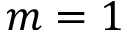Convert formula to latex. <formula><loc_0><loc_0><loc_500><loc_500>m = 1</formula> 